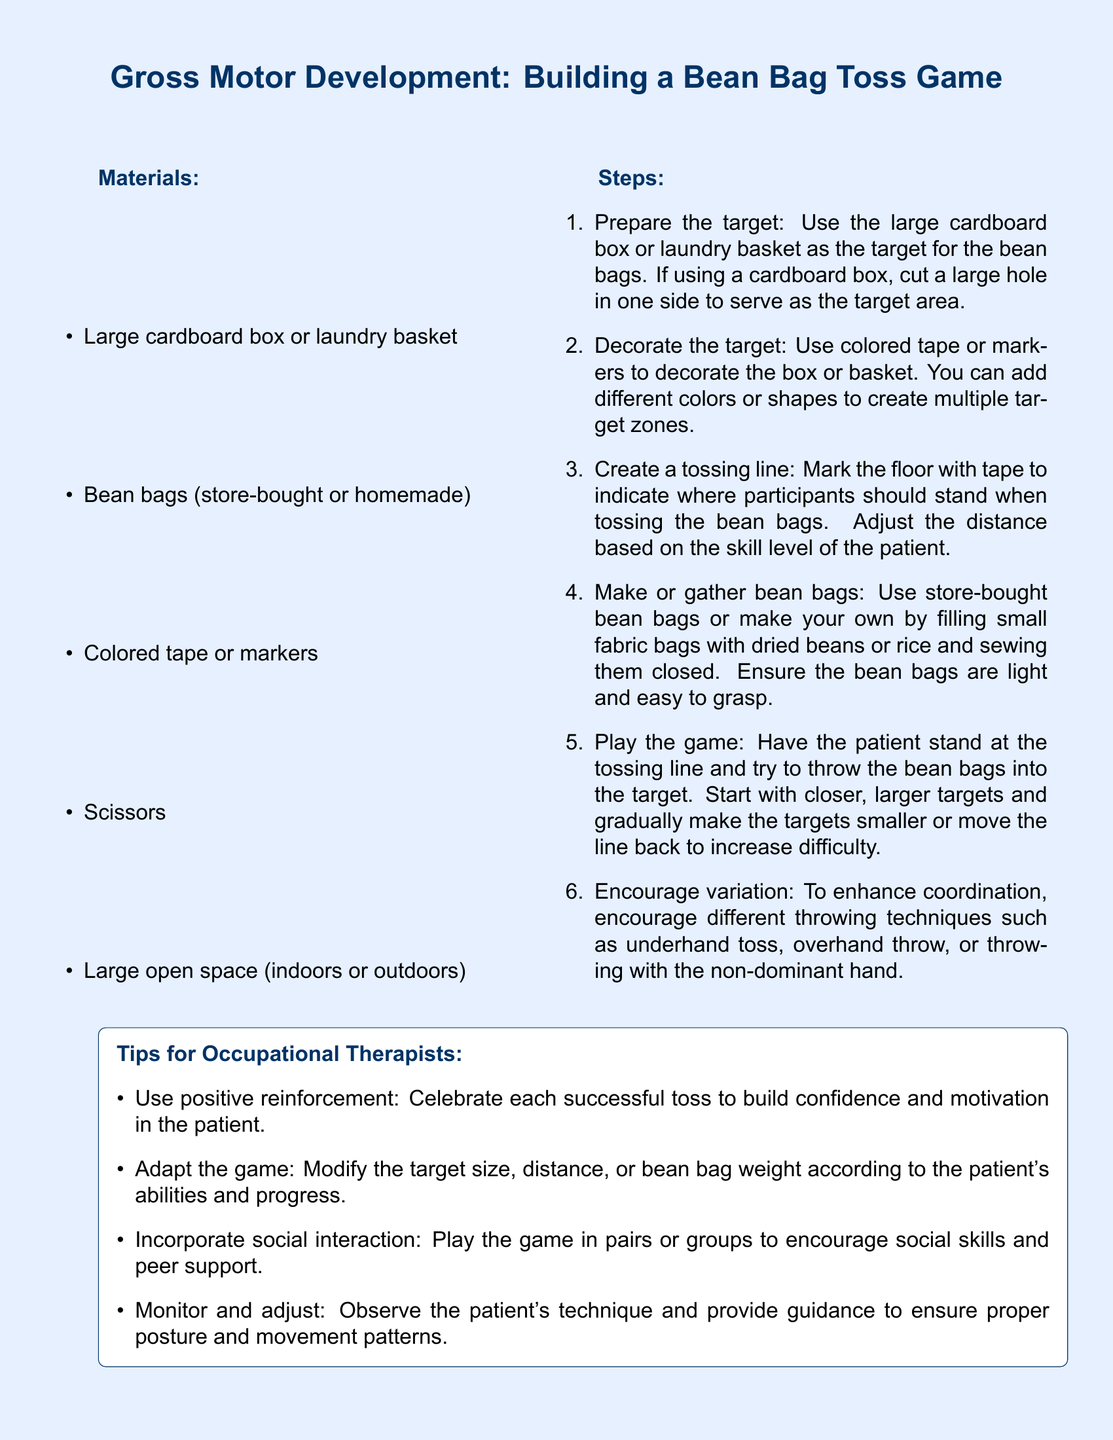What is the target for the bean bags? The target for the bean bags is a large cardboard box or laundry basket.
Answer: cardboard box or laundry basket What materials are needed to create the bean bag toss game? The materials needed include a large cardboard box or laundry basket, bean bags, colored tape or markers, scissors, and a large open space.
Answer: large cardboard box or laundry basket, bean bags, colored tape or markers, scissors, large open space How many steps are there in the recipe? The recipe contains six steps for building the game.
Answer: six What should be done to enhance coordination during the game? To enhance coordination, various throwing techniques such as underhand toss, overhand throw, or throwing with the non-dominant hand should be encouraged.
Answer: encourage different throwing techniques What is one tip for occupational therapists? One tip for occupational therapists is to use positive reinforcement.
Answer: use positive reinforcement What does the recipe card suggest for the tossing line? The recipe suggests marking the floor with tape to indicate where participants should stand when tossing the bean bags.
Answer: marking the floor with tape What can be done to adapt the game? The game can be adapted by modifying the target size, distance, or bean bag weight.
Answer: modify target size, distance, or bean bag weight What type of game is being built? The game being built is a bean bag toss game.
Answer: bean bag toss game 